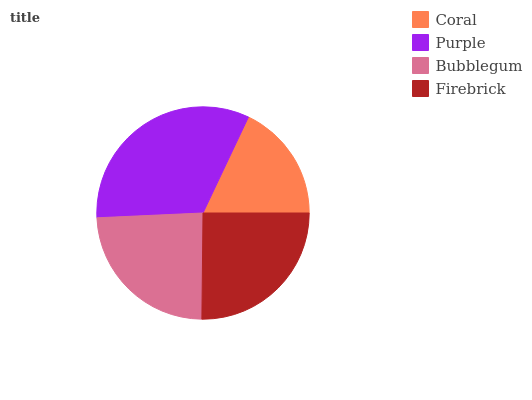Is Coral the minimum?
Answer yes or no. Yes. Is Purple the maximum?
Answer yes or no. Yes. Is Bubblegum the minimum?
Answer yes or no. No. Is Bubblegum the maximum?
Answer yes or no. No. Is Purple greater than Bubblegum?
Answer yes or no. Yes. Is Bubblegum less than Purple?
Answer yes or no. Yes. Is Bubblegum greater than Purple?
Answer yes or no. No. Is Purple less than Bubblegum?
Answer yes or no. No. Is Firebrick the high median?
Answer yes or no. Yes. Is Bubblegum the low median?
Answer yes or no. Yes. Is Coral the high median?
Answer yes or no. No. Is Coral the low median?
Answer yes or no. No. 